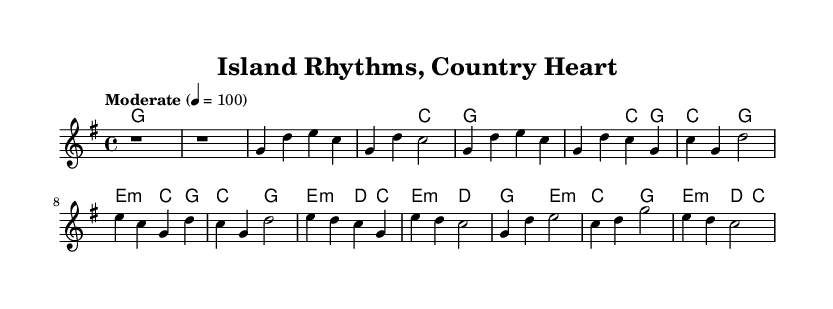What is the key signature of this music? The key signature is G major, which has one sharp (F#). This is determined by looking at the key signature indicated at the beginning of the sheet music.
Answer: G major What is the time signature of this music? The time signature is 4/4, as seen at the beginning of the score, indicating four beats per measure with a quarter note receiving one beat.
Answer: 4/4 What is the tempo marking in the music? The tempo marking is "Moderate" with a metronome marking of 100 BPM, found in the tempo indication section of the score.
Answer: Moderate 4 = 100 How many measures are in the Chorus section? The Chorus consists of 4 measures, as evident by counting the measures from the start to the end of the Chorus labeled section.
Answer: 4 What are the first three chords used in the verse? The first three chords in the verse are G, G, and C, identified in the harmonies section corresponding to the melody notes.
Answer: G, G, C Which type of chord appears frequently in this music? The major chord appears frequently, particularly in chords G, C, and E major, noted throughout the harmonies section of the sheet music.
Answer: Major Which section includes a bridge in the music? The section labeled "Bridge" includes the bridge, which is defined in the structure of the song, marking a transition before returning to the Chorus.
Answer: Bridge 